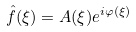<formula> <loc_0><loc_0><loc_500><loc_500>\hat { f } ( \xi ) = A ( \xi ) e ^ { i \varphi ( \xi ) }</formula> 